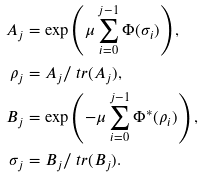<formula> <loc_0><loc_0><loc_500><loc_500>A _ { j } & = \exp \left ( \mu \sum _ { i = 0 } ^ { j - 1 } \Phi ( \sigma _ { i } ) \right ) , \\ \rho _ { j } & = A _ { j } / \ t r ( A _ { j } ) , \\ B _ { j } & = \exp \left ( - \mu \sum _ { i = 0 } ^ { j - 1 } \Phi ^ { \ast } ( \rho _ { i } ) \right ) , \\ \sigma _ { j } & = B _ { j } / \ t r ( B _ { j } ) .</formula> 